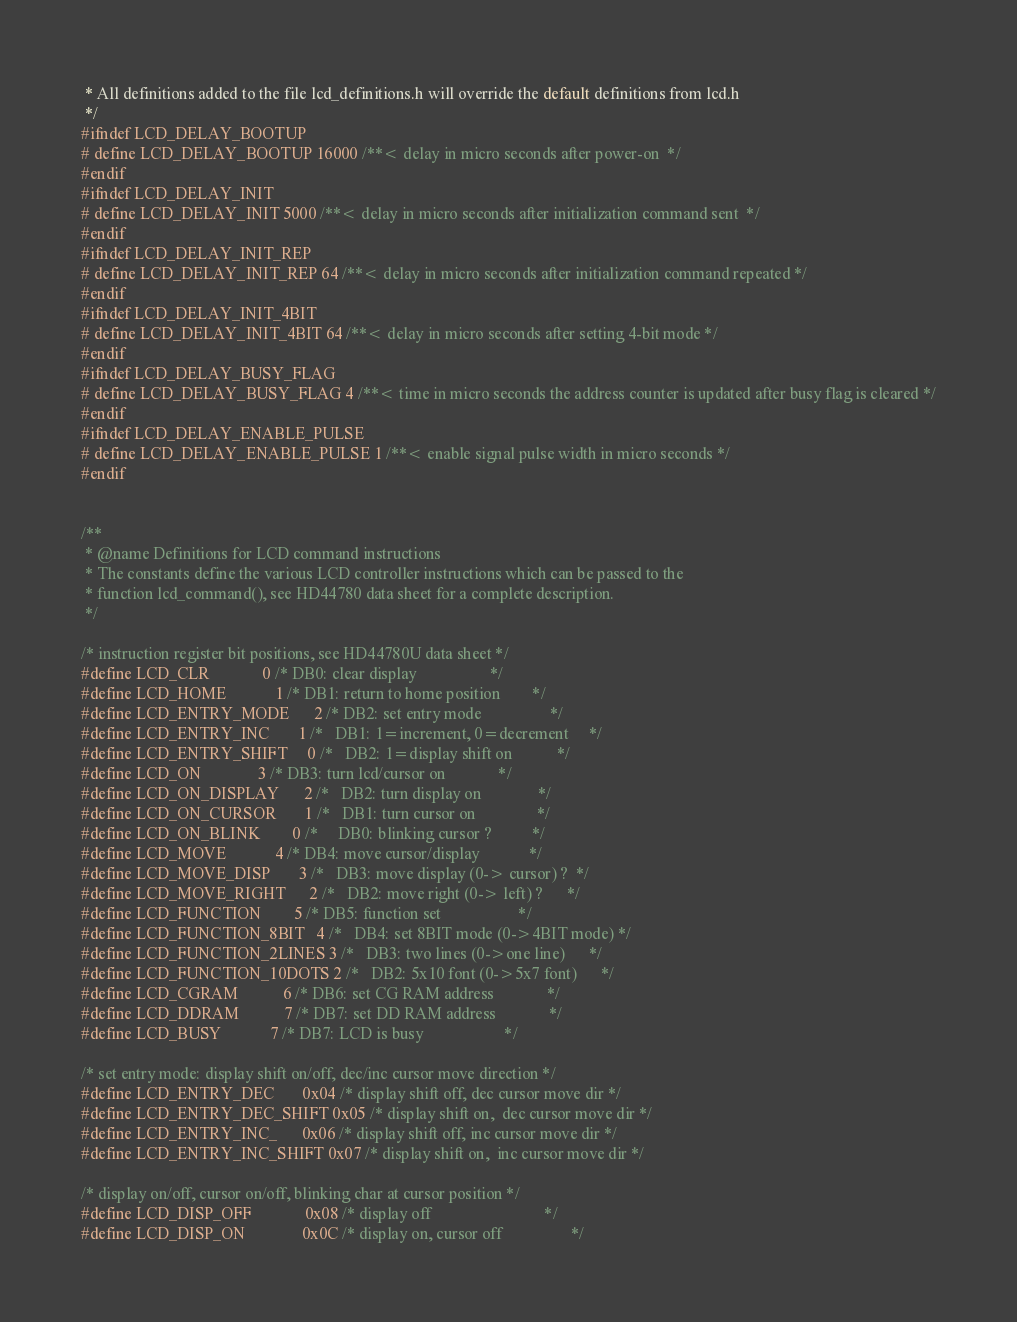Convert code to text. <code><loc_0><loc_0><loc_500><loc_500><_C_> * All definitions added to the file lcd_definitions.h will override the default definitions from lcd.h
 */
#ifndef LCD_DELAY_BOOTUP
# define LCD_DELAY_BOOTUP 16000 /**< delay in micro seconds after power-on  */
#endif
#ifndef LCD_DELAY_INIT
# define LCD_DELAY_INIT 5000 /**< delay in micro seconds after initialization command sent  */
#endif
#ifndef LCD_DELAY_INIT_REP
# define LCD_DELAY_INIT_REP 64 /**< delay in micro seconds after initialization command repeated */
#endif
#ifndef LCD_DELAY_INIT_4BIT
# define LCD_DELAY_INIT_4BIT 64 /**< delay in micro seconds after setting 4-bit mode */
#endif
#ifndef LCD_DELAY_BUSY_FLAG
# define LCD_DELAY_BUSY_FLAG 4 /**< time in micro seconds the address counter is updated after busy flag is cleared */
#endif
#ifndef LCD_DELAY_ENABLE_PULSE
# define LCD_DELAY_ENABLE_PULSE 1 /**< enable signal pulse width in micro seconds */
#endif


/**
 * @name Definitions for LCD command instructions
 * The constants define the various LCD controller instructions which can be passed to the
 * function lcd_command(), see HD44780 data sheet for a complete description.
 */

/* instruction register bit positions, see HD44780U data sheet */
#define LCD_CLR             0 /* DB0: clear display                  */
#define LCD_HOME            1 /* DB1: return to home position        */
#define LCD_ENTRY_MODE      2 /* DB2: set entry mode                 */
#define LCD_ENTRY_INC       1 /*   DB1: 1=increment, 0=decrement     */
#define LCD_ENTRY_SHIFT     0 /*   DB2: 1=display shift on           */
#define LCD_ON              3 /* DB3: turn lcd/cursor on             */
#define LCD_ON_DISPLAY      2 /*   DB2: turn display on              */
#define LCD_ON_CURSOR       1 /*   DB1: turn cursor on               */
#define LCD_ON_BLINK        0 /*     DB0: blinking cursor ?          */
#define LCD_MOVE            4 /* DB4: move cursor/display            */
#define LCD_MOVE_DISP       3 /*   DB3: move display (0-> cursor) ?  */
#define LCD_MOVE_RIGHT      2 /*   DB2: move right (0-> left) ?      */
#define LCD_FUNCTION        5 /* DB5: function set                   */
#define LCD_FUNCTION_8BIT   4 /*   DB4: set 8BIT mode (0->4BIT mode) */
#define LCD_FUNCTION_2LINES 3 /*   DB3: two lines (0->one line)      */
#define LCD_FUNCTION_10DOTS 2 /*   DB2: 5x10 font (0->5x7 font)      */
#define LCD_CGRAM           6 /* DB6: set CG RAM address             */
#define LCD_DDRAM           7 /* DB7: set DD RAM address             */
#define LCD_BUSY            7 /* DB7: LCD is busy                    */

/* set entry mode: display shift on/off, dec/inc cursor move direction */
#define LCD_ENTRY_DEC       0x04 /* display shift off, dec cursor move dir */
#define LCD_ENTRY_DEC_SHIFT 0x05 /* display shift on,  dec cursor move dir */
#define LCD_ENTRY_INC_      0x06 /* display shift off, inc cursor move dir */
#define LCD_ENTRY_INC_SHIFT 0x07 /* display shift on,  inc cursor move dir */

/* display on/off, cursor on/off, blinking char at cursor position */
#define LCD_DISP_OFF             0x08 /* display off                            */
#define LCD_DISP_ON              0x0C /* display on, cursor off                 */</code> 